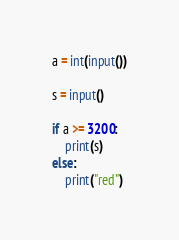<code> <loc_0><loc_0><loc_500><loc_500><_Python_>a = int(input())

s = input()

if a >= 3200:
    print(s)
else:
    print("red")</code> 